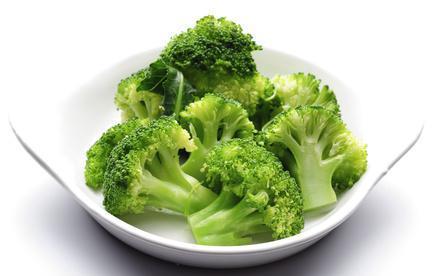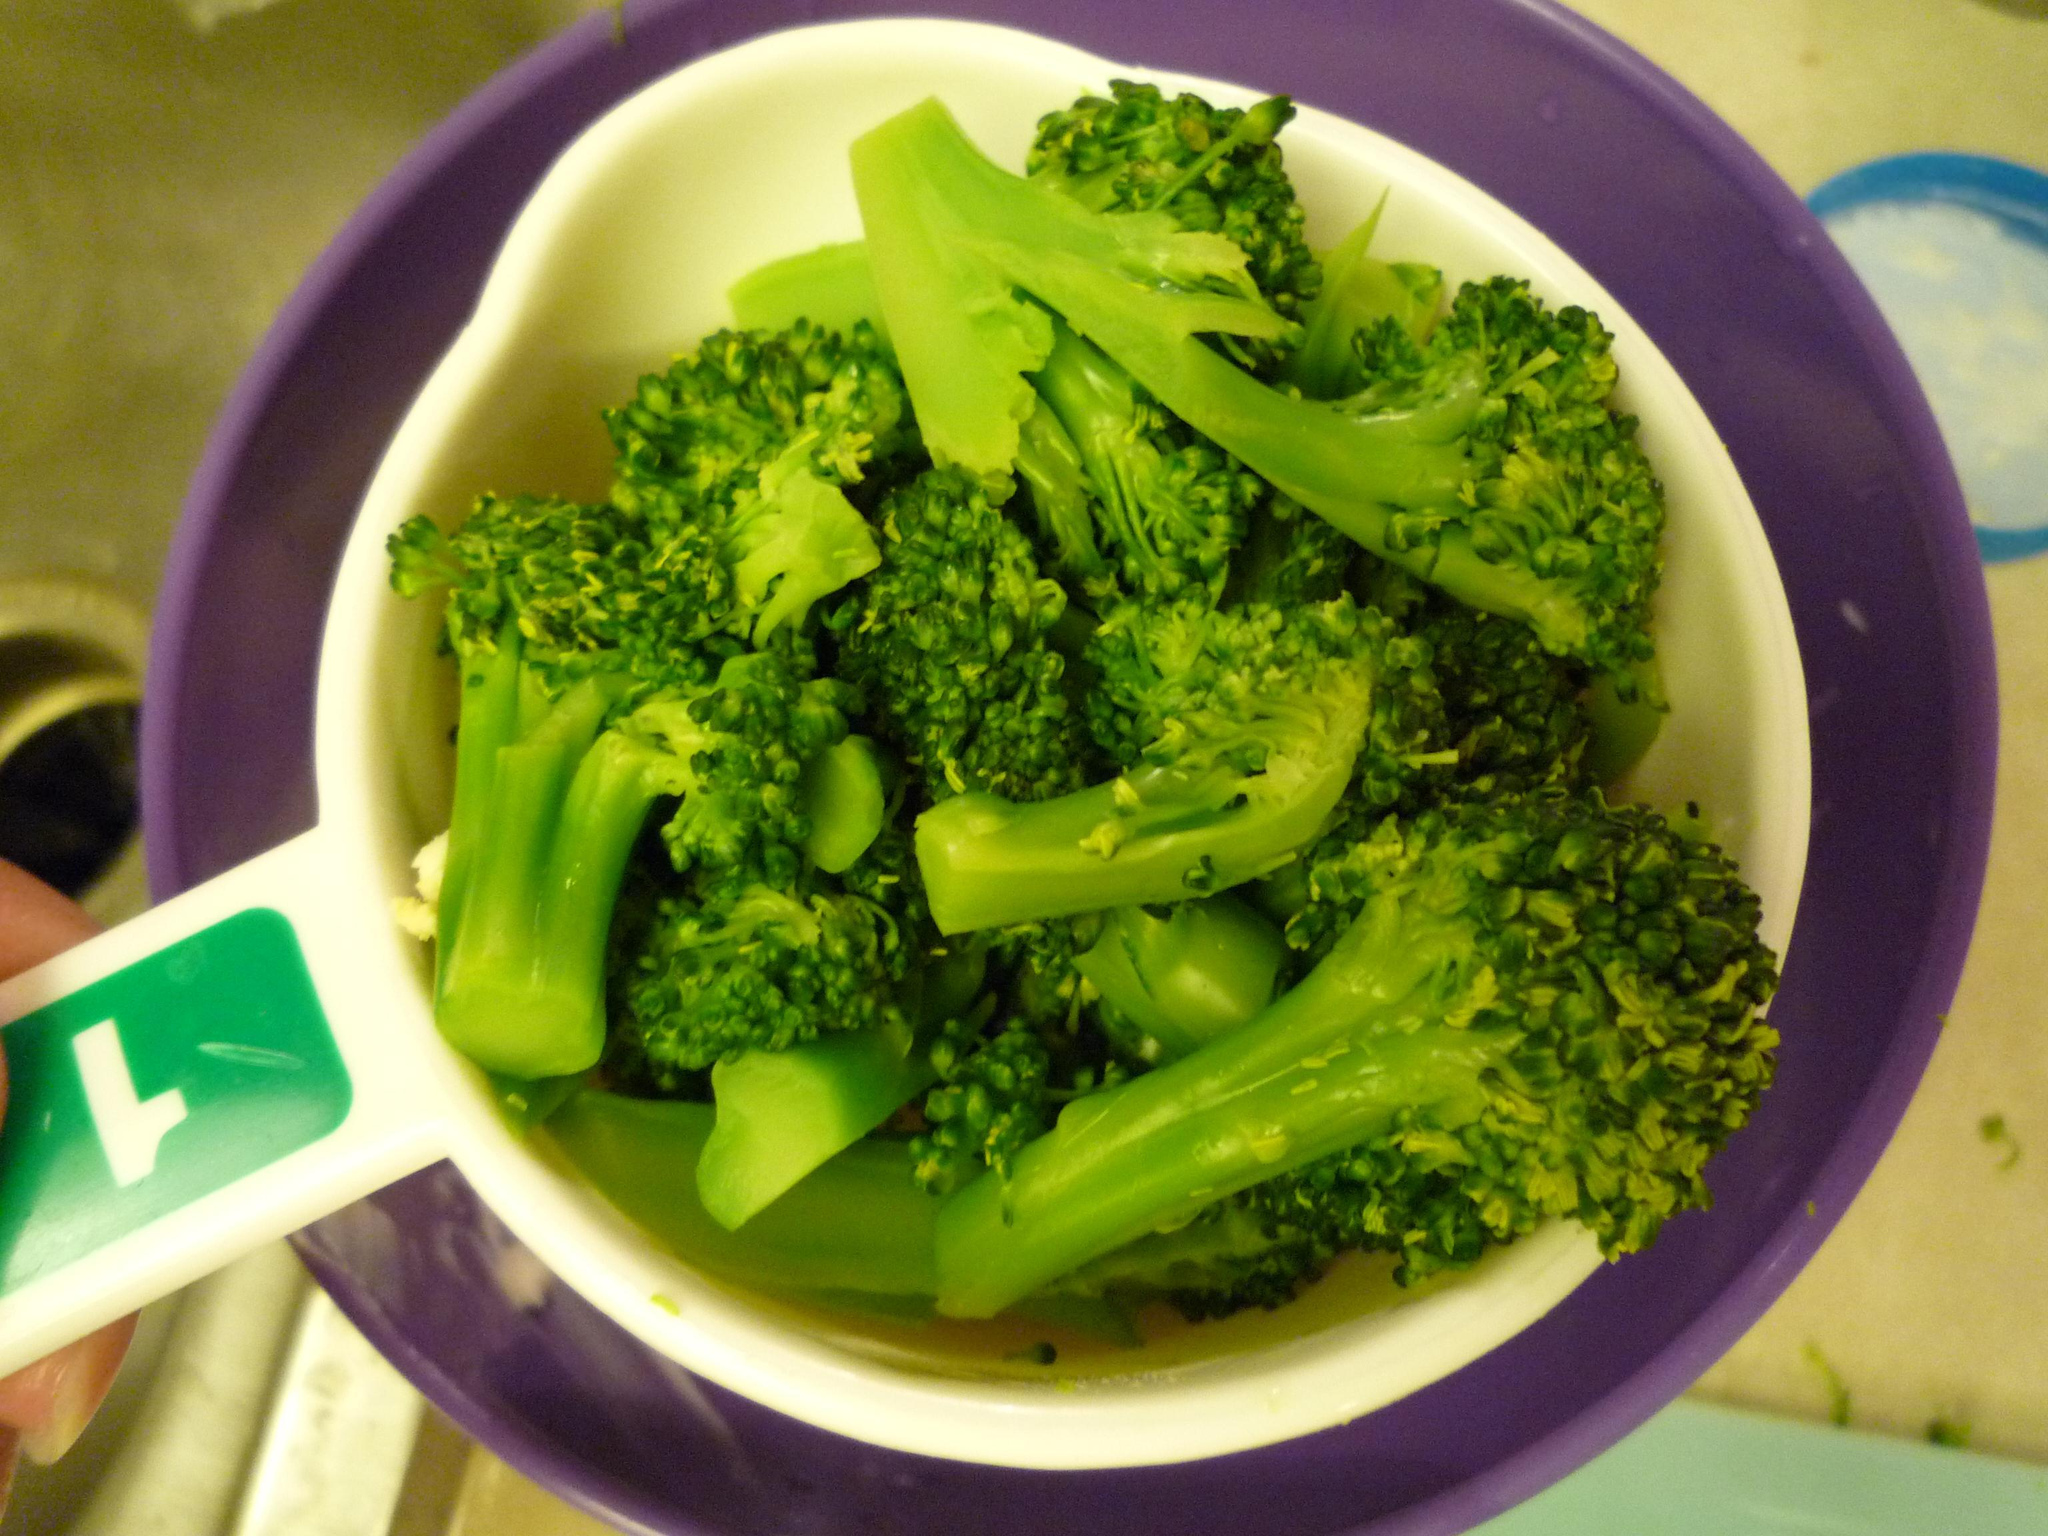The first image is the image on the left, the second image is the image on the right. Examine the images to the left and right. Is the description "An image shows broccoli in a round container with one handle." accurate? Answer yes or no. Yes. 